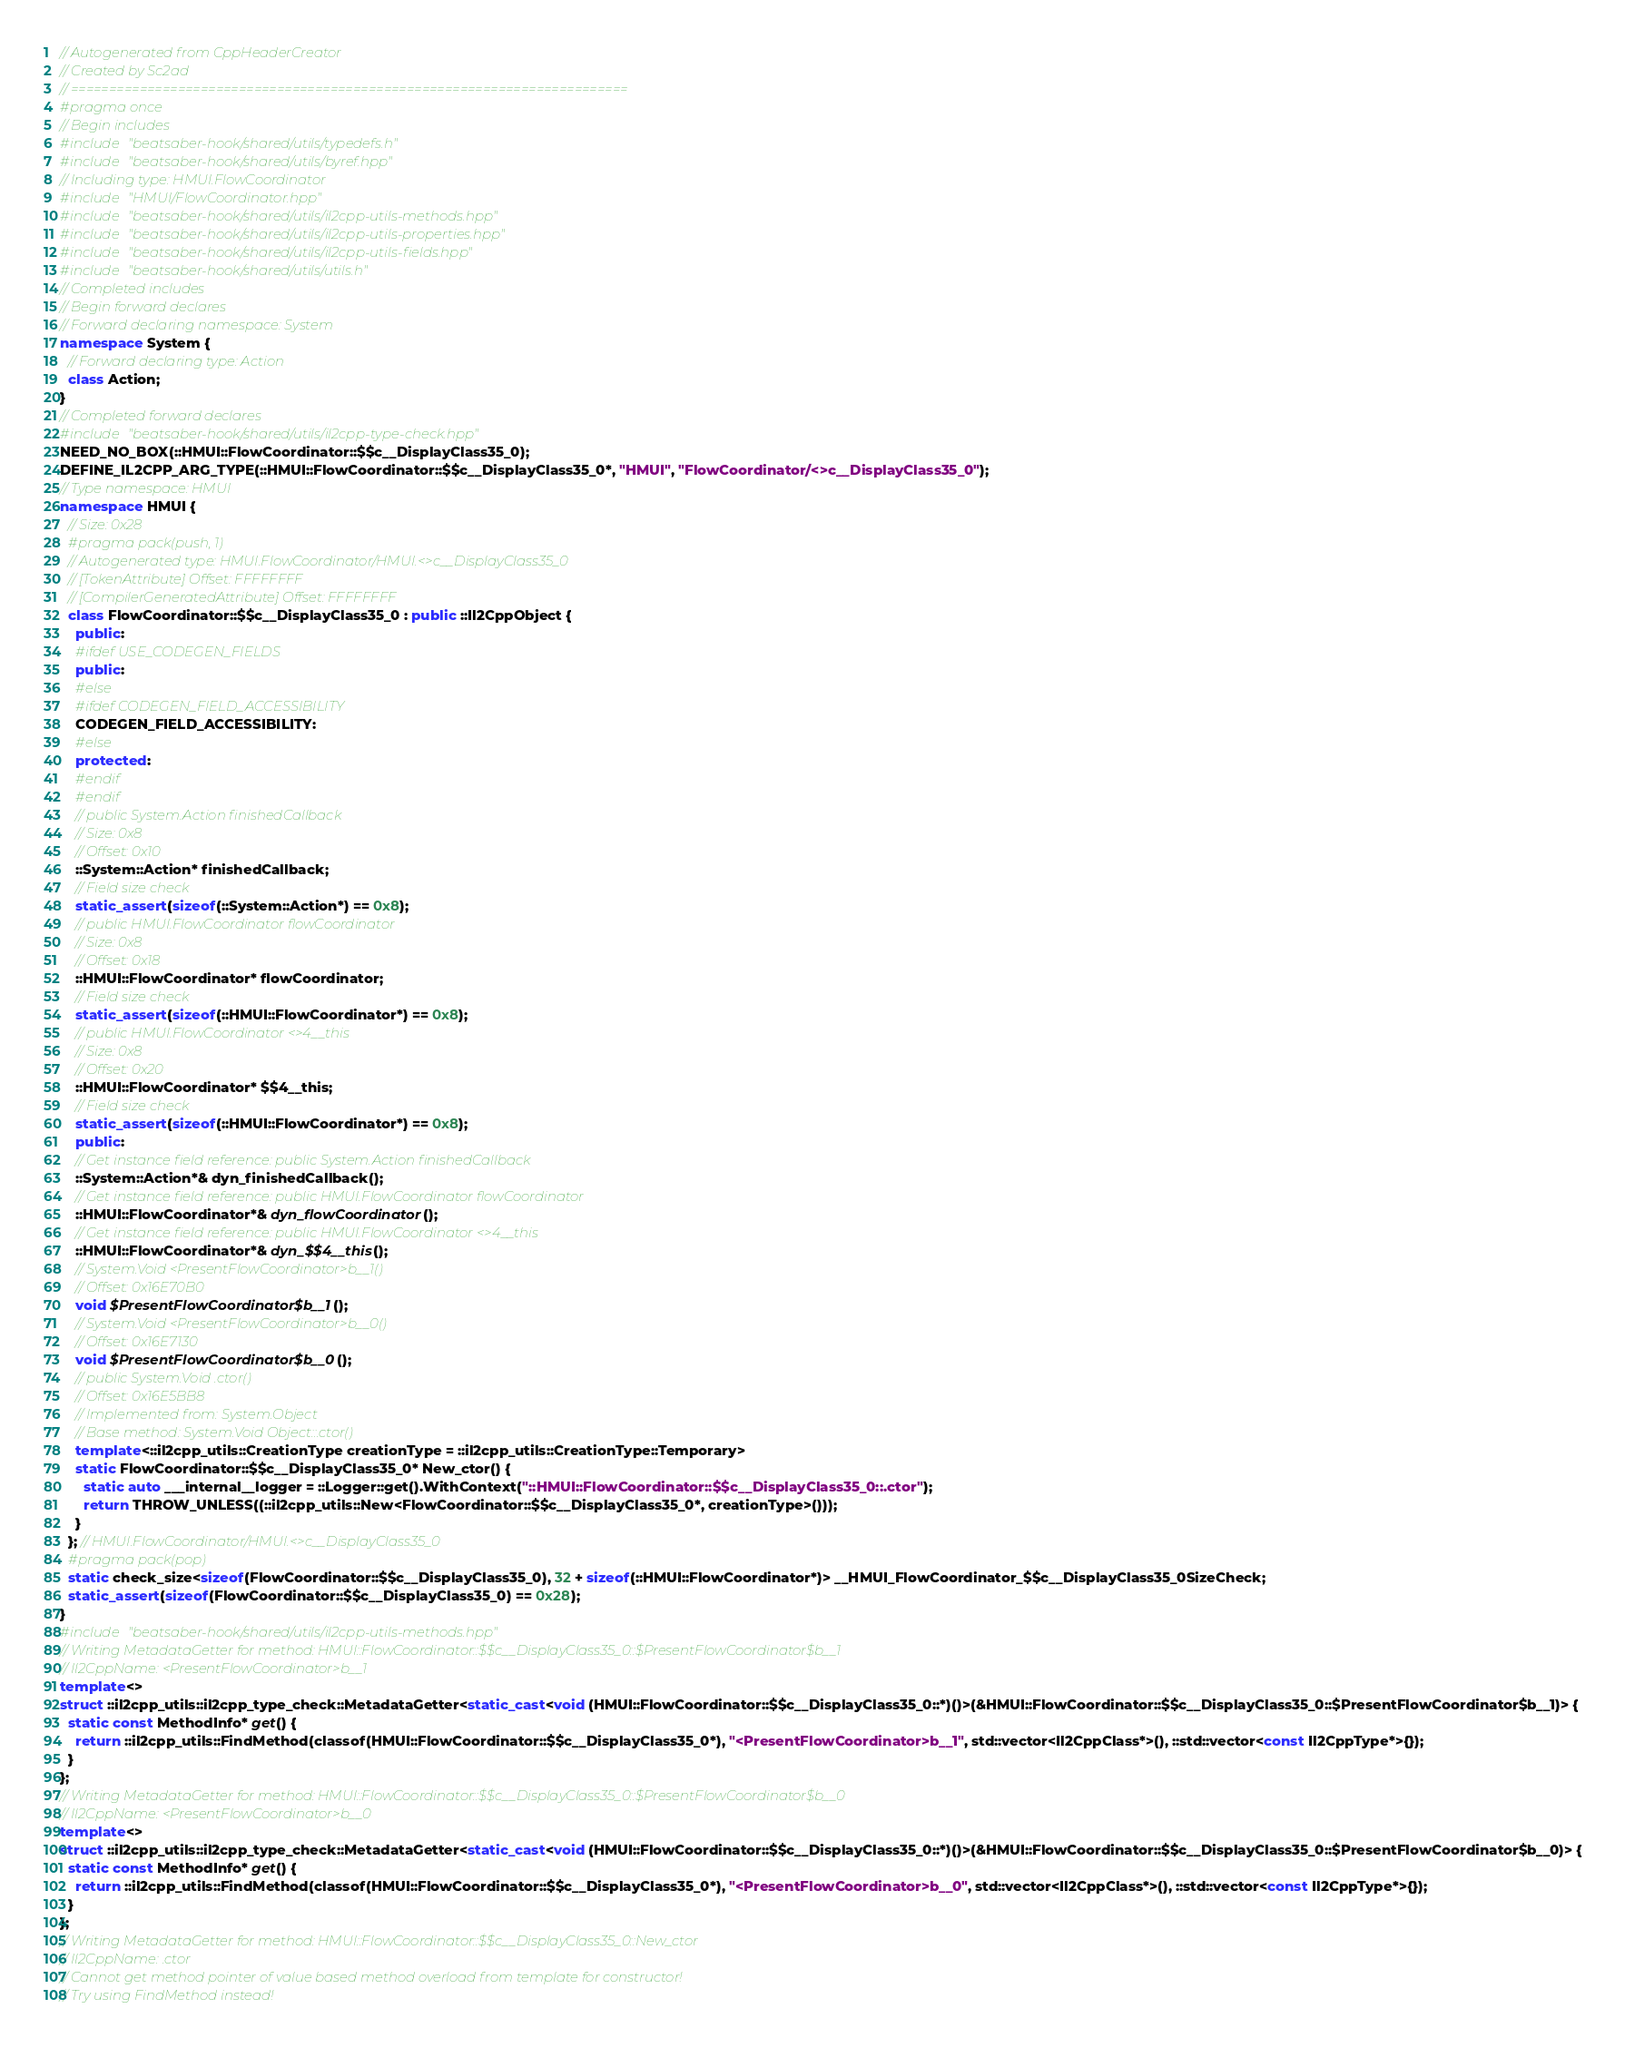<code> <loc_0><loc_0><loc_500><loc_500><_C++_>// Autogenerated from CppHeaderCreator
// Created by Sc2ad
// =========================================================================
#pragma once
// Begin includes
#include "beatsaber-hook/shared/utils/typedefs.h"
#include "beatsaber-hook/shared/utils/byref.hpp"
// Including type: HMUI.FlowCoordinator
#include "HMUI/FlowCoordinator.hpp"
#include "beatsaber-hook/shared/utils/il2cpp-utils-methods.hpp"
#include "beatsaber-hook/shared/utils/il2cpp-utils-properties.hpp"
#include "beatsaber-hook/shared/utils/il2cpp-utils-fields.hpp"
#include "beatsaber-hook/shared/utils/utils.h"
// Completed includes
// Begin forward declares
// Forward declaring namespace: System
namespace System {
  // Forward declaring type: Action
  class Action;
}
// Completed forward declares
#include "beatsaber-hook/shared/utils/il2cpp-type-check.hpp"
NEED_NO_BOX(::HMUI::FlowCoordinator::$$c__DisplayClass35_0);
DEFINE_IL2CPP_ARG_TYPE(::HMUI::FlowCoordinator::$$c__DisplayClass35_0*, "HMUI", "FlowCoordinator/<>c__DisplayClass35_0");
// Type namespace: HMUI
namespace HMUI {
  // Size: 0x28
  #pragma pack(push, 1)
  // Autogenerated type: HMUI.FlowCoordinator/HMUI.<>c__DisplayClass35_0
  // [TokenAttribute] Offset: FFFFFFFF
  // [CompilerGeneratedAttribute] Offset: FFFFFFFF
  class FlowCoordinator::$$c__DisplayClass35_0 : public ::Il2CppObject {
    public:
    #ifdef USE_CODEGEN_FIELDS
    public:
    #else
    #ifdef CODEGEN_FIELD_ACCESSIBILITY
    CODEGEN_FIELD_ACCESSIBILITY:
    #else
    protected:
    #endif
    #endif
    // public System.Action finishedCallback
    // Size: 0x8
    // Offset: 0x10
    ::System::Action* finishedCallback;
    // Field size check
    static_assert(sizeof(::System::Action*) == 0x8);
    // public HMUI.FlowCoordinator flowCoordinator
    // Size: 0x8
    // Offset: 0x18
    ::HMUI::FlowCoordinator* flowCoordinator;
    // Field size check
    static_assert(sizeof(::HMUI::FlowCoordinator*) == 0x8);
    // public HMUI.FlowCoordinator <>4__this
    // Size: 0x8
    // Offset: 0x20
    ::HMUI::FlowCoordinator* $$4__this;
    // Field size check
    static_assert(sizeof(::HMUI::FlowCoordinator*) == 0x8);
    public:
    // Get instance field reference: public System.Action finishedCallback
    ::System::Action*& dyn_finishedCallback();
    // Get instance field reference: public HMUI.FlowCoordinator flowCoordinator
    ::HMUI::FlowCoordinator*& dyn_flowCoordinator();
    // Get instance field reference: public HMUI.FlowCoordinator <>4__this
    ::HMUI::FlowCoordinator*& dyn_$$4__this();
    // System.Void <PresentFlowCoordinator>b__1()
    // Offset: 0x16E70B0
    void $PresentFlowCoordinator$b__1();
    // System.Void <PresentFlowCoordinator>b__0()
    // Offset: 0x16E7130
    void $PresentFlowCoordinator$b__0();
    // public System.Void .ctor()
    // Offset: 0x16E5BB8
    // Implemented from: System.Object
    // Base method: System.Void Object::.ctor()
    template<::il2cpp_utils::CreationType creationType = ::il2cpp_utils::CreationType::Temporary>
    static FlowCoordinator::$$c__DisplayClass35_0* New_ctor() {
      static auto ___internal__logger = ::Logger::get().WithContext("::HMUI::FlowCoordinator::$$c__DisplayClass35_0::.ctor");
      return THROW_UNLESS((::il2cpp_utils::New<FlowCoordinator::$$c__DisplayClass35_0*, creationType>()));
    }
  }; // HMUI.FlowCoordinator/HMUI.<>c__DisplayClass35_0
  #pragma pack(pop)
  static check_size<sizeof(FlowCoordinator::$$c__DisplayClass35_0), 32 + sizeof(::HMUI::FlowCoordinator*)> __HMUI_FlowCoordinator_$$c__DisplayClass35_0SizeCheck;
  static_assert(sizeof(FlowCoordinator::$$c__DisplayClass35_0) == 0x28);
}
#include "beatsaber-hook/shared/utils/il2cpp-utils-methods.hpp"
// Writing MetadataGetter for method: HMUI::FlowCoordinator::$$c__DisplayClass35_0::$PresentFlowCoordinator$b__1
// Il2CppName: <PresentFlowCoordinator>b__1
template<>
struct ::il2cpp_utils::il2cpp_type_check::MetadataGetter<static_cast<void (HMUI::FlowCoordinator::$$c__DisplayClass35_0::*)()>(&HMUI::FlowCoordinator::$$c__DisplayClass35_0::$PresentFlowCoordinator$b__1)> {
  static const MethodInfo* get() {
    return ::il2cpp_utils::FindMethod(classof(HMUI::FlowCoordinator::$$c__DisplayClass35_0*), "<PresentFlowCoordinator>b__1", std::vector<Il2CppClass*>(), ::std::vector<const Il2CppType*>{});
  }
};
// Writing MetadataGetter for method: HMUI::FlowCoordinator::$$c__DisplayClass35_0::$PresentFlowCoordinator$b__0
// Il2CppName: <PresentFlowCoordinator>b__0
template<>
struct ::il2cpp_utils::il2cpp_type_check::MetadataGetter<static_cast<void (HMUI::FlowCoordinator::$$c__DisplayClass35_0::*)()>(&HMUI::FlowCoordinator::$$c__DisplayClass35_0::$PresentFlowCoordinator$b__0)> {
  static const MethodInfo* get() {
    return ::il2cpp_utils::FindMethod(classof(HMUI::FlowCoordinator::$$c__DisplayClass35_0*), "<PresentFlowCoordinator>b__0", std::vector<Il2CppClass*>(), ::std::vector<const Il2CppType*>{});
  }
};
// Writing MetadataGetter for method: HMUI::FlowCoordinator::$$c__DisplayClass35_0::New_ctor
// Il2CppName: .ctor
// Cannot get method pointer of value based method overload from template for constructor!
// Try using FindMethod instead!
</code> 